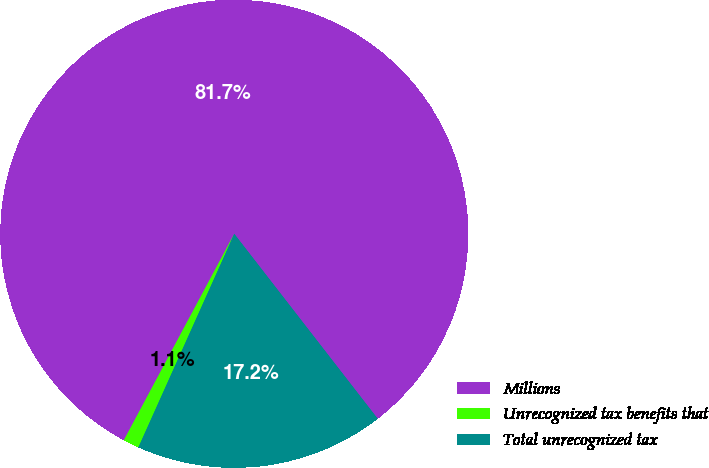<chart> <loc_0><loc_0><loc_500><loc_500><pie_chart><fcel>Millions<fcel>Unrecognized tax benefits that<fcel>Total unrecognized tax<nl><fcel>81.69%<fcel>1.1%<fcel>17.22%<nl></chart> 